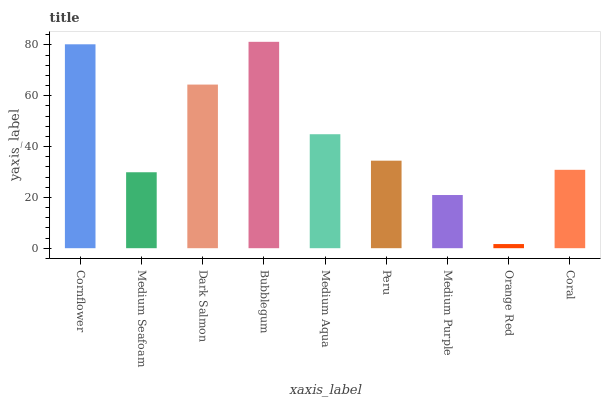Is Orange Red the minimum?
Answer yes or no. Yes. Is Bubblegum the maximum?
Answer yes or no. Yes. Is Medium Seafoam the minimum?
Answer yes or no. No. Is Medium Seafoam the maximum?
Answer yes or no. No. Is Cornflower greater than Medium Seafoam?
Answer yes or no. Yes. Is Medium Seafoam less than Cornflower?
Answer yes or no. Yes. Is Medium Seafoam greater than Cornflower?
Answer yes or no. No. Is Cornflower less than Medium Seafoam?
Answer yes or no. No. Is Peru the high median?
Answer yes or no. Yes. Is Peru the low median?
Answer yes or no. Yes. Is Dark Salmon the high median?
Answer yes or no. No. Is Medium Aqua the low median?
Answer yes or no. No. 